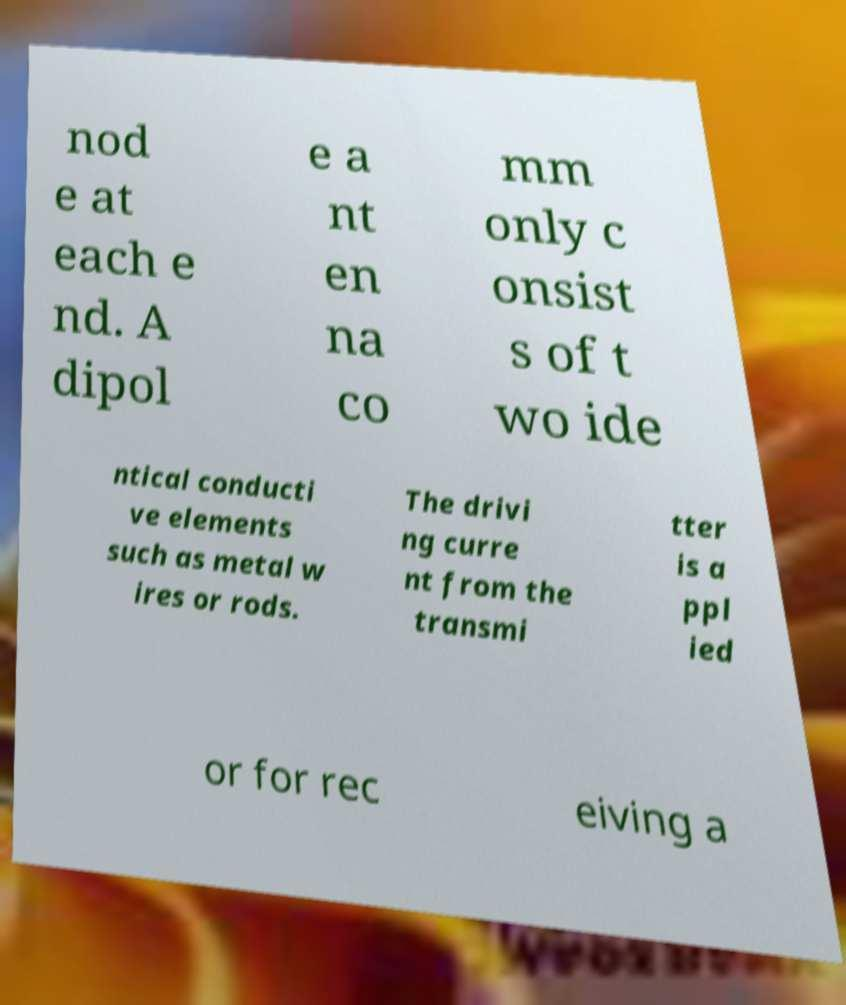There's text embedded in this image that I need extracted. Can you transcribe it verbatim? nod e at each e nd. A dipol e a nt en na co mm only c onsist s of t wo ide ntical conducti ve elements such as metal w ires or rods. The drivi ng curre nt from the transmi tter is a ppl ied or for rec eiving a 